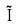Convert formula to latex. <formula><loc_0><loc_0><loc_500><loc_500>\tilde { I }</formula> 